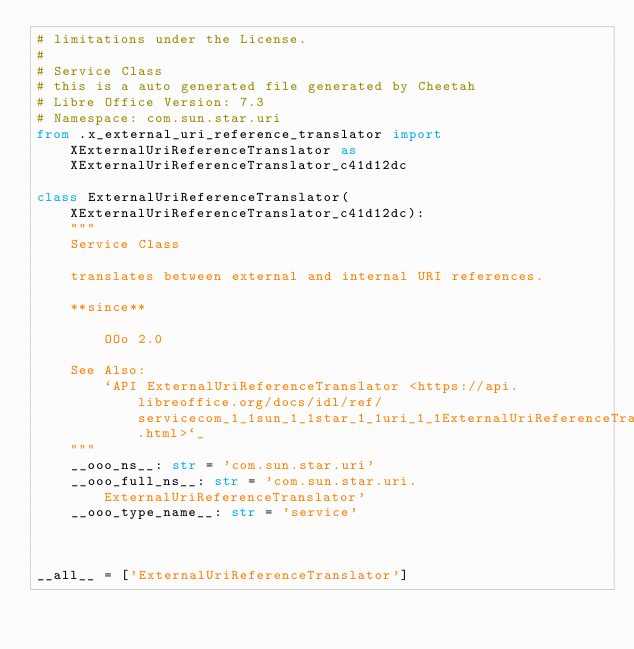Convert code to text. <code><loc_0><loc_0><loc_500><loc_500><_Python_># limitations under the License.
#
# Service Class
# this is a auto generated file generated by Cheetah
# Libre Office Version: 7.3
# Namespace: com.sun.star.uri
from .x_external_uri_reference_translator import XExternalUriReferenceTranslator as XExternalUriReferenceTranslator_c41d12dc

class ExternalUriReferenceTranslator(XExternalUriReferenceTranslator_c41d12dc):
    """
    Service Class

    translates between external and internal URI references.
    
    **since**
    
        OOo 2.0

    See Also:
        `API ExternalUriReferenceTranslator <https://api.libreoffice.org/docs/idl/ref/servicecom_1_1sun_1_1star_1_1uri_1_1ExternalUriReferenceTranslator.html>`_
    """
    __ooo_ns__: str = 'com.sun.star.uri'
    __ooo_full_ns__: str = 'com.sun.star.uri.ExternalUriReferenceTranslator'
    __ooo_type_name__: str = 'service'



__all__ = ['ExternalUriReferenceTranslator']

</code> 